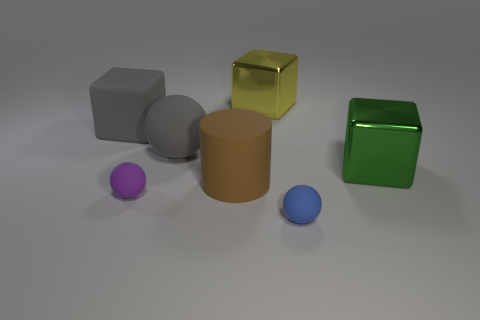Add 2 large yellow cubes. How many objects exist? 9 Subtract all purple rubber spheres. How many spheres are left? 2 Subtract all green spheres. How many gray cubes are left? 1 Subtract all brown matte things. Subtract all big yellow cubes. How many objects are left? 5 Add 5 balls. How many balls are left? 8 Add 3 yellow metal objects. How many yellow metal objects exist? 4 Subtract 0 red cubes. How many objects are left? 7 Subtract all spheres. How many objects are left? 4 Subtract all green cylinders. Subtract all yellow blocks. How many cylinders are left? 1 